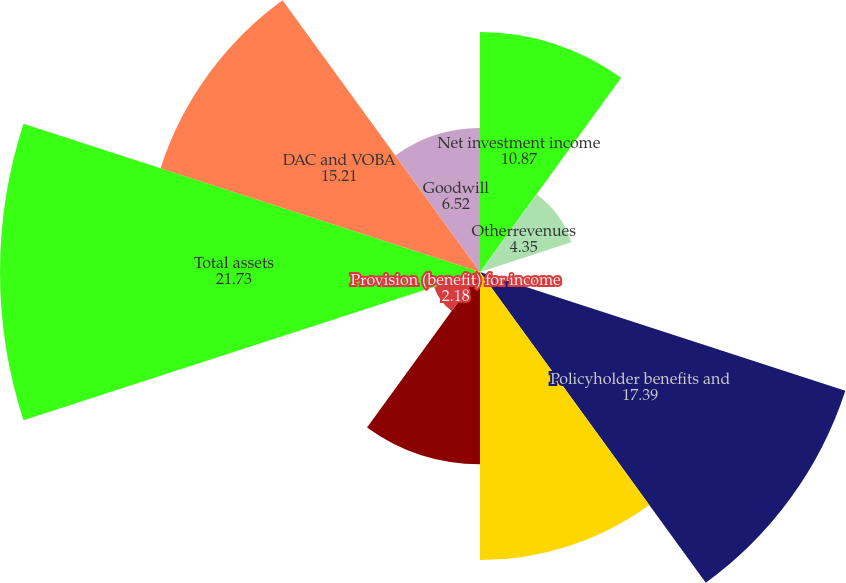Convert chart. <chart><loc_0><loc_0><loc_500><loc_500><pie_chart><fcel>Net investment income<fcel>Otherrevenues<fcel>Net investment gains (losses)<fcel>Policyholder benefits and<fcel>Other expenses<fcel>Income (loss) from continuing<fcel>Provision (benefit) for income<fcel>Total assets<fcel>DAC and VOBA<fcel>Goodwill<nl><fcel>10.87%<fcel>4.35%<fcel>0.01%<fcel>17.39%<fcel>13.04%<fcel>8.7%<fcel>2.18%<fcel>21.73%<fcel>15.21%<fcel>6.52%<nl></chart> 